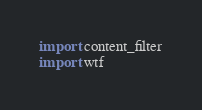<code> <loc_0><loc_0><loc_500><loc_500><_Python_>import content_filter
import wtf
</code> 